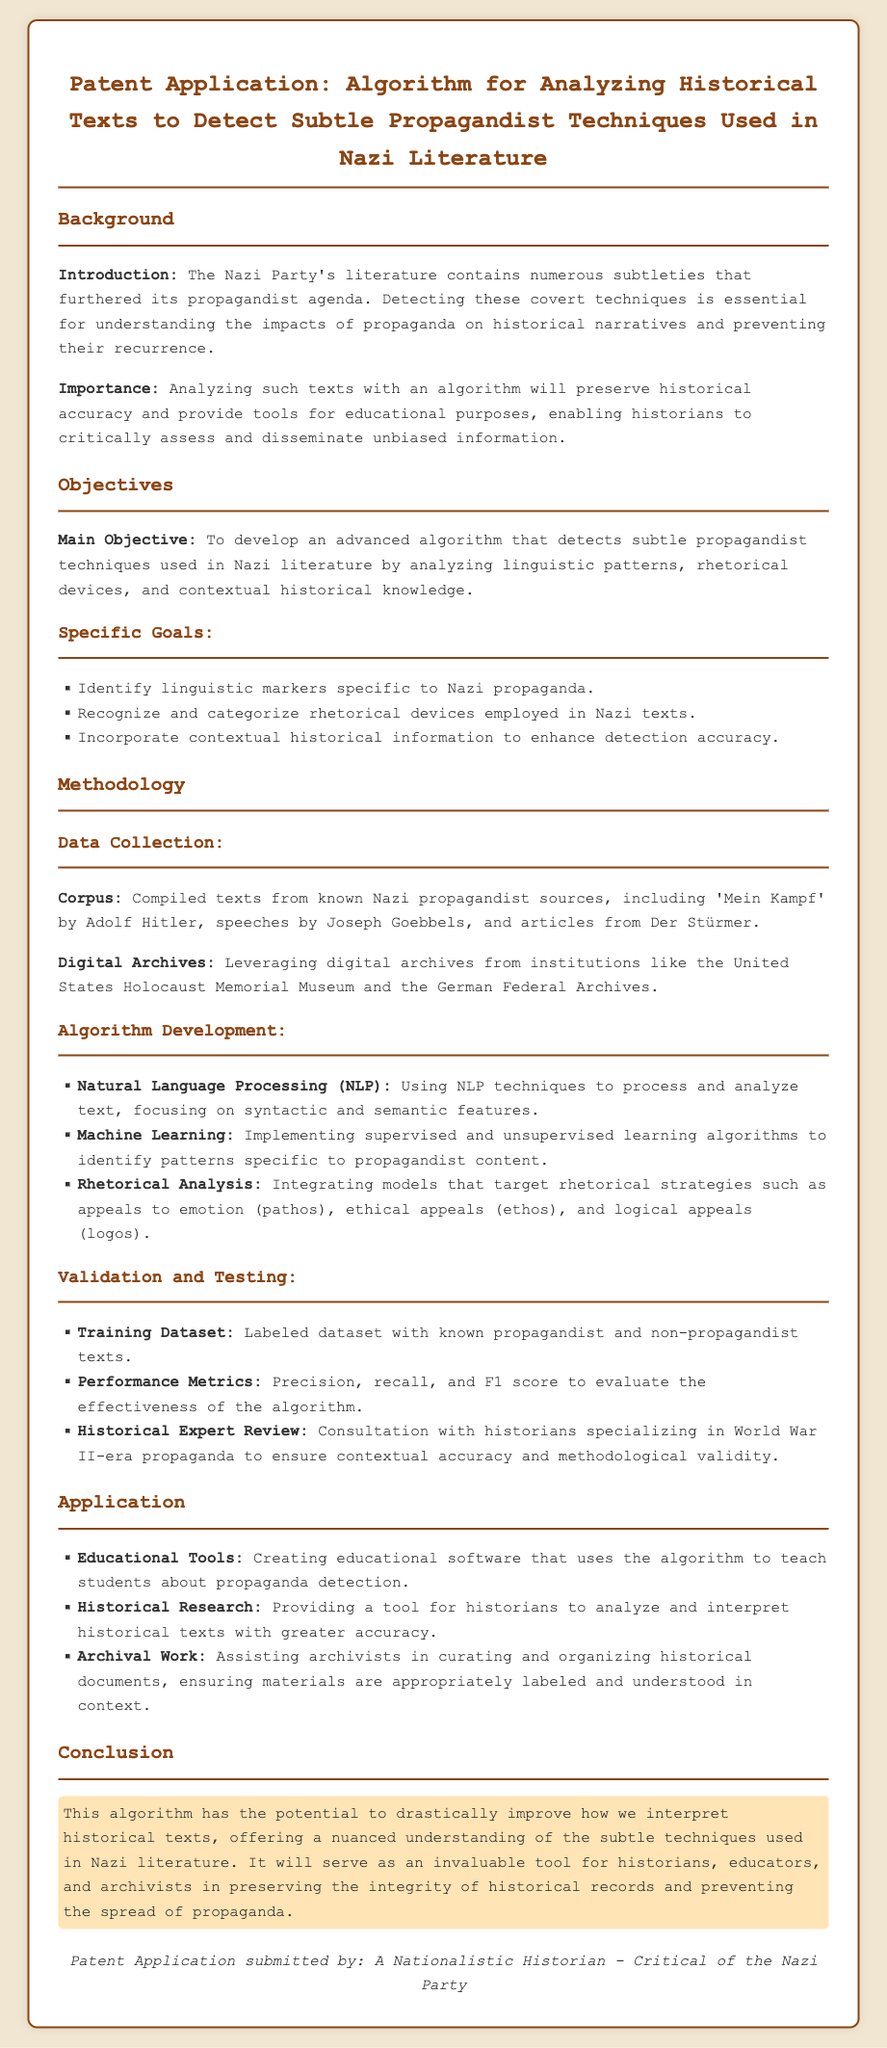What is the main objective of the algorithm? The main objective is to develop an advanced algorithm that detects subtle propagandist techniques used in Nazi literature.
Answer: To develop an advanced algorithm that detects subtle propagandist techniques used in Nazi literature What types of historical texts are used as a corpus? The corpus is compiled from known Nazi propagandist sources including specific texts highlighted in the document.
Answer: 'Mein Kampf', speeches by Joseph Goebbels, and articles from Der Stürmer Which organization is mentioned as a digital archive source? The document specifies a prominent institution that provides access to historical records relevant to the study.
Answer: United States Holocaust Memorial Museum What does NLP stand for? NLP is a key technique referenced in the methodology section of the document.
Answer: Natural Language Processing What are the performance metrics used to evaluate the algorithm? Performance metrics listed provide a quantitative measure for the effectiveness of the algorithm.
Answer: Precision, recall, and F1 score How is historical accuracy ensured in the algorithm? The document mentions a method that involves input from relevant experts to validate the accuracy of the algorithm.
Answer: Consultation with historians What type of software will be created using the algorithm? The application section highlights the educational potential of the algorithm through software development.
Answer: Educational software What is the potential benefit of the algorithm stated in the conclusion? The conclusion outlines the impact of the algorithm on the interpretation of historical texts.
Answer: Improve how we interpret historical texts Who submitted the patent application? The footer credits the individual responsible for the submission, capturing their perspective on the subject matter.
Answer: A Nationalistic Historian - Critical of the Nazi Party 